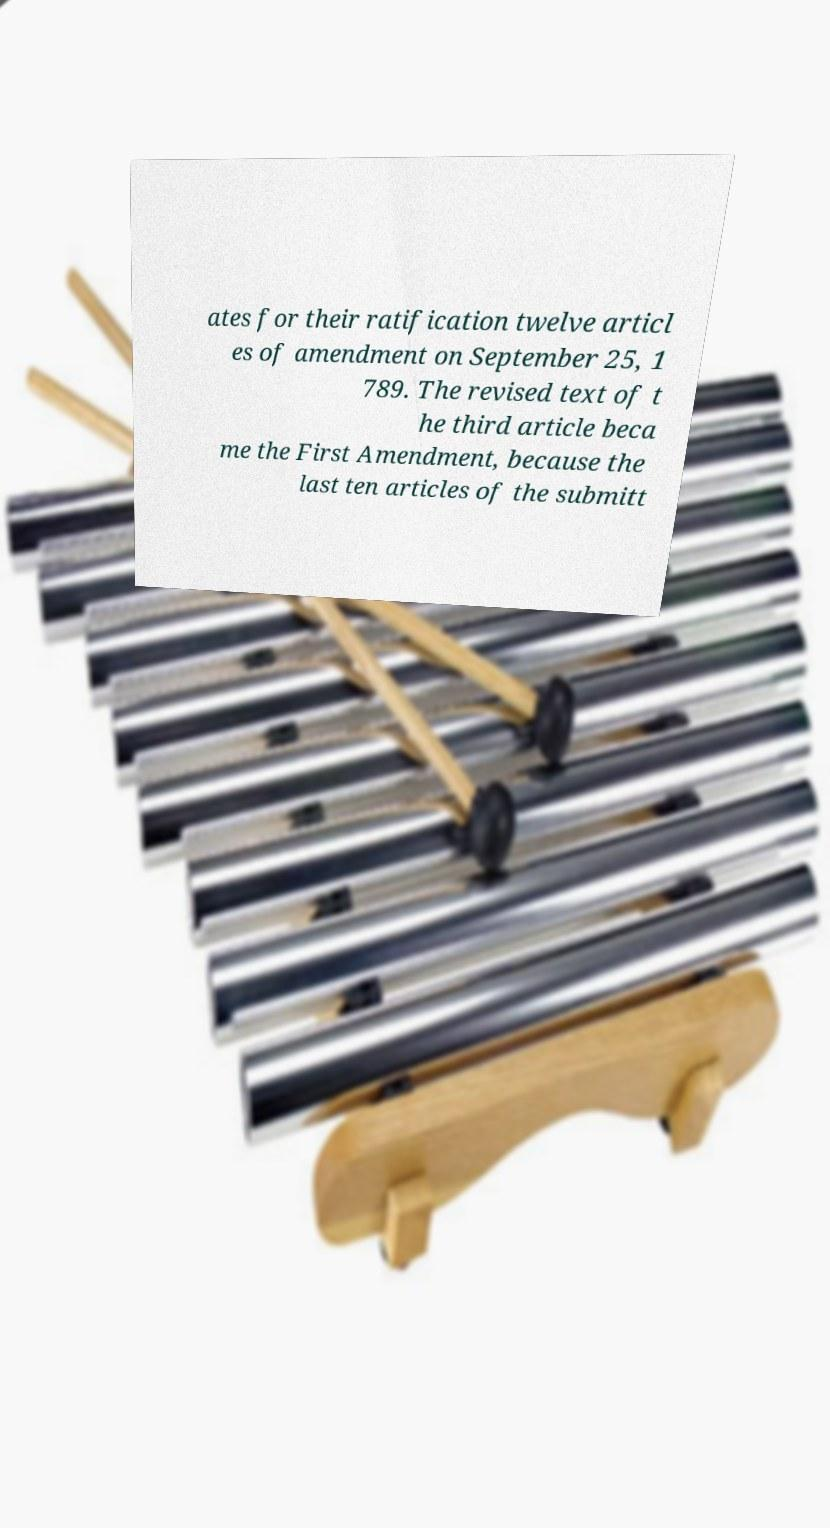Please read and relay the text visible in this image. What does it say? ates for their ratification twelve articl es of amendment on September 25, 1 789. The revised text of t he third article beca me the First Amendment, because the last ten articles of the submitt 